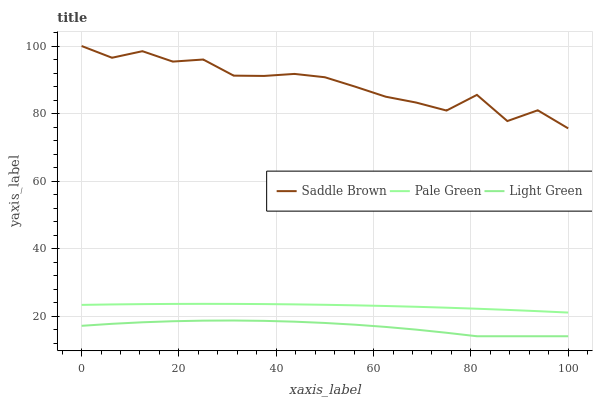Does Light Green have the minimum area under the curve?
Answer yes or no. Yes. Does Saddle Brown have the maximum area under the curve?
Answer yes or no. Yes. Does Saddle Brown have the minimum area under the curve?
Answer yes or no. No. Does Light Green have the maximum area under the curve?
Answer yes or no. No. Is Pale Green the smoothest?
Answer yes or no. Yes. Is Saddle Brown the roughest?
Answer yes or no. Yes. Is Light Green the smoothest?
Answer yes or no. No. Is Light Green the roughest?
Answer yes or no. No. Does Light Green have the lowest value?
Answer yes or no. Yes. Does Saddle Brown have the lowest value?
Answer yes or no. No. Does Saddle Brown have the highest value?
Answer yes or no. Yes. Does Light Green have the highest value?
Answer yes or no. No. Is Light Green less than Pale Green?
Answer yes or no. Yes. Is Saddle Brown greater than Light Green?
Answer yes or no. Yes. Does Light Green intersect Pale Green?
Answer yes or no. No. 